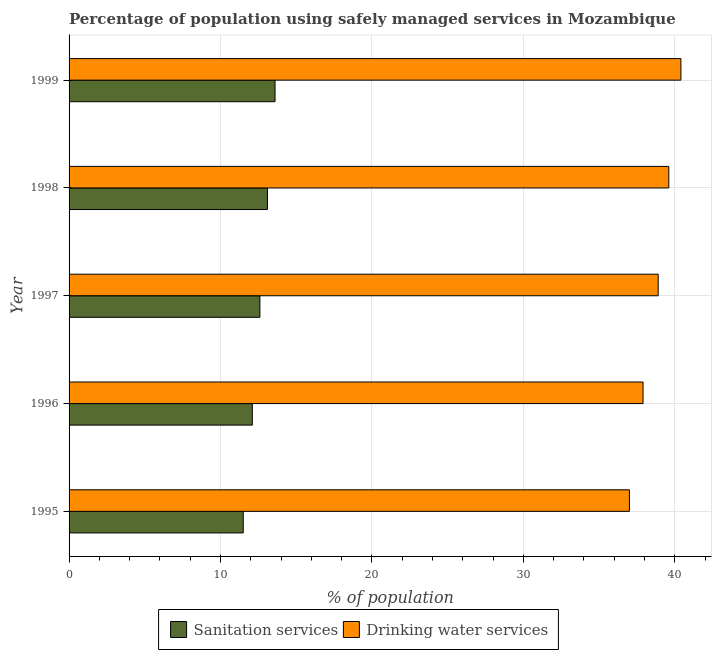How many different coloured bars are there?
Your answer should be very brief. 2. Are the number of bars on each tick of the Y-axis equal?
Provide a succinct answer. Yes. How many bars are there on the 1st tick from the top?
Offer a terse response. 2. In how many cases, is the number of bars for a given year not equal to the number of legend labels?
Provide a succinct answer. 0. What is the total percentage of population who used sanitation services in the graph?
Your answer should be compact. 62.9. What is the average percentage of population who used sanitation services per year?
Your answer should be compact. 12.58. In the year 1998, what is the difference between the percentage of population who used drinking water services and percentage of population who used sanitation services?
Offer a very short reply. 26.5. What is the ratio of the percentage of population who used sanitation services in 1997 to that in 1999?
Your response must be concise. 0.93. What is the difference between the highest and the second highest percentage of population who used sanitation services?
Your response must be concise. 0.5. What is the difference between the highest and the lowest percentage of population who used drinking water services?
Your response must be concise. 3.4. What does the 1st bar from the top in 1995 represents?
Your answer should be very brief. Drinking water services. What does the 1st bar from the bottom in 1997 represents?
Keep it short and to the point. Sanitation services. Are all the bars in the graph horizontal?
Make the answer very short. Yes. What is the difference between two consecutive major ticks on the X-axis?
Make the answer very short. 10. Are the values on the major ticks of X-axis written in scientific E-notation?
Make the answer very short. No. Does the graph contain any zero values?
Make the answer very short. No. Does the graph contain grids?
Your response must be concise. Yes. Where does the legend appear in the graph?
Your response must be concise. Bottom center. How are the legend labels stacked?
Your answer should be compact. Horizontal. What is the title of the graph?
Make the answer very short. Percentage of population using safely managed services in Mozambique. What is the label or title of the X-axis?
Make the answer very short. % of population. What is the % of population in Sanitation services in 1995?
Provide a succinct answer. 11.5. What is the % of population in Drinking water services in 1996?
Make the answer very short. 37.9. What is the % of population in Drinking water services in 1997?
Offer a very short reply. 38.9. What is the % of population of Drinking water services in 1998?
Keep it short and to the point. 39.6. What is the % of population in Drinking water services in 1999?
Offer a very short reply. 40.4. Across all years, what is the maximum % of population in Drinking water services?
Offer a terse response. 40.4. What is the total % of population in Sanitation services in the graph?
Provide a succinct answer. 62.9. What is the total % of population in Drinking water services in the graph?
Make the answer very short. 193.8. What is the difference between the % of population in Sanitation services in 1995 and that in 1996?
Your response must be concise. -0.6. What is the difference between the % of population of Sanitation services in 1995 and that in 1997?
Your answer should be very brief. -1.1. What is the difference between the % of population of Drinking water services in 1995 and that in 1997?
Provide a short and direct response. -1.9. What is the difference between the % of population of Sanitation services in 1995 and that in 1998?
Offer a terse response. -1.6. What is the difference between the % of population in Sanitation services in 1995 and that in 1999?
Offer a very short reply. -2.1. What is the difference between the % of population of Drinking water services in 1995 and that in 1999?
Offer a terse response. -3.4. What is the difference between the % of population in Sanitation services in 1996 and that in 1997?
Make the answer very short. -0.5. What is the difference between the % of population of Sanitation services in 1996 and that in 1998?
Provide a succinct answer. -1. What is the difference between the % of population of Sanitation services in 1996 and that in 1999?
Keep it short and to the point. -1.5. What is the difference between the % of population in Sanitation services in 1997 and that in 1998?
Provide a succinct answer. -0.5. What is the difference between the % of population of Sanitation services in 1997 and that in 1999?
Provide a short and direct response. -1. What is the difference between the % of population in Sanitation services in 1998 and that in 1999?
Offer a terse response. -0.5. What is the difference between the % of population of Drinking water services in 1998 and that in 1999?
Make the answer very short. -0.8. What is the difference between the % of population of Sanitation services in 1995 and the % of population of Drinking water services in 1996?
Your answer should be compact. -26.4. What is the difference between the % of population of Sanitation services in 1995 and the % of population of Drinking water services in 1997?
Give a very brief answer. -27.4. What is the difference between the % of population in Sanitation services in 1995 and the % of population in Drinking water services in 1998?
Your answer should be very brief. -28.1. What is the difference between the % of population of Sanitation services in 1995 and the % of population of Drinking water services in 1999?
Keep it short and to the point. -28.9. What is the difference between the % of population in Sanitation services in 1996 and the % of population in Drinking water services in 1997?
Your answer should be very brief. -26.8. What is the difference between the % of population of Sanitation services in 1996 and the % of population of Drinking water services in 1998?
Ensure brevity in your answer.  -27.5. What is the difference between the % of population in Sanitation services in 1996 and the % of population in Drinking water services in 1999?
Your response must be concise. -28.3. What is the difference between the % of population of Sanitation services in 1997 and the % of population of Drinking water services in 1999?
Ensure brevity in your answer.  -27.8. What is the difference between the % of population in Sanitation services in 1998 and the % of population in Drinking water services in 1999?
Ensure brevity in your answer.  -27.3. What is the average % of population of Sanitation services per year?
Your answer should be very brief. 12.58. What is the average % of population in Drinking water services per year?
Provide a short and direct response. 38.76. In the year 1995, what is the difference between the % of population in Sanitation services and % of population in Drinking water services?
Offer a terse response. -25.5. In the year 1996, what is the difference between the % of population of Sanitation services and % of population of Drinking water services?
Give a very brief answer. -25.8. In the year 1997, what is the difference between the % of population in Sanitation services and % of population in Drinking water services?
Your answer should be very brief. -26.3. In the year 1998, what is the difference between the % of population of Sanitation services and % of population of Drinking water services?
Your answer should be very brief. -26.5. In the year 1999, what is the difference between the % of population in Sanitation services and % of population in Drinking water services?
Keep it short and to the point. -26.8. What is the ratio of the % of population in Sanitation services in 1995 to that in 1996?
Make the answer very short. 0.95. What is the ratio of the % of population of Drinking water services in 1995 to that in 1996?
Offer a terse response. 0.98. What is the ratio of the % of population of Sanitation services in 1995 to that in 1997?
Offer a very short reply. 0.91. What is the ratio of the % of population in Drinking water services in 1995 to that in 1997?
Give a very brief answer. 0.95. What is the ratio of the % of population in Sanitation services in 1995 to that in 1998?
Your response must be concise. 0.88. What is the ratio of the % of population in Drinking water services in 1995 to that in 1998?
Provide a short and direct response. 0.93. What is the ratio of the % of population in Sanitation services in 1995 to that in 1999?
Make the answer very short. 0.85. What is the ratio of the % of population in Drinking water services in 1995 to that in 1999?
Make the answer very short. 0.92. What is the ratio of the % of population of Sanitation services in 1996 to that in 1997?
Provide a succinct answer. 0.96. What is the ratio of the % of population of Drinking water services in 1996 to that in 1997?
Provide a succinct answer. 0.97. What is the ratio of the % of population of Sanitation services in 1996 to that in 1998?
Ensure brevity in your answer.  0.92. What is the ratio of the % of population in Drinking water services in 1996 to that in 1998?
Give a very brief answer. 0.96. What is the ratio of the % of population of Sanitation services in 1996 to that in 1999?
Keep it short and to the point. 0.89. What is the ratio of the % of population in Drinking water services in 1996 to that in 1999?
Offer a very short reply. 0.94. What is the ratio of the % of population of Sanitation services in 1997 to that in 1998?
Make the answer very short. 0.96. What is the ratio of the % of population of Drinking water services in 1997 to that in 1998?
Your answer should be very brief. 0.98. What is the ratio of the % of population in Sanitation services in 1997 to that in 1999?
Offer a very short reply. 0.93. What is the ratio of the % of population of Drinking water services in 1997 to that in 1999?
Give a very brief answer. 0.96. What is the ratio of the % of population of Sanitation services in 1998 to that in 1999?
Provide a succinct answer. 0.96. What is the ratio of the % of population of Drinking water services in 1998 to that in 1999?
Offer a very short reply. 0.98. What is the difference between the highest and the second highest % of population of Drinking water services?
Provide a succinct answer. 0.8. What is the difference between the highest and the lowest % of population in Drinking water services?
Give a very brief answer. 3.4. 